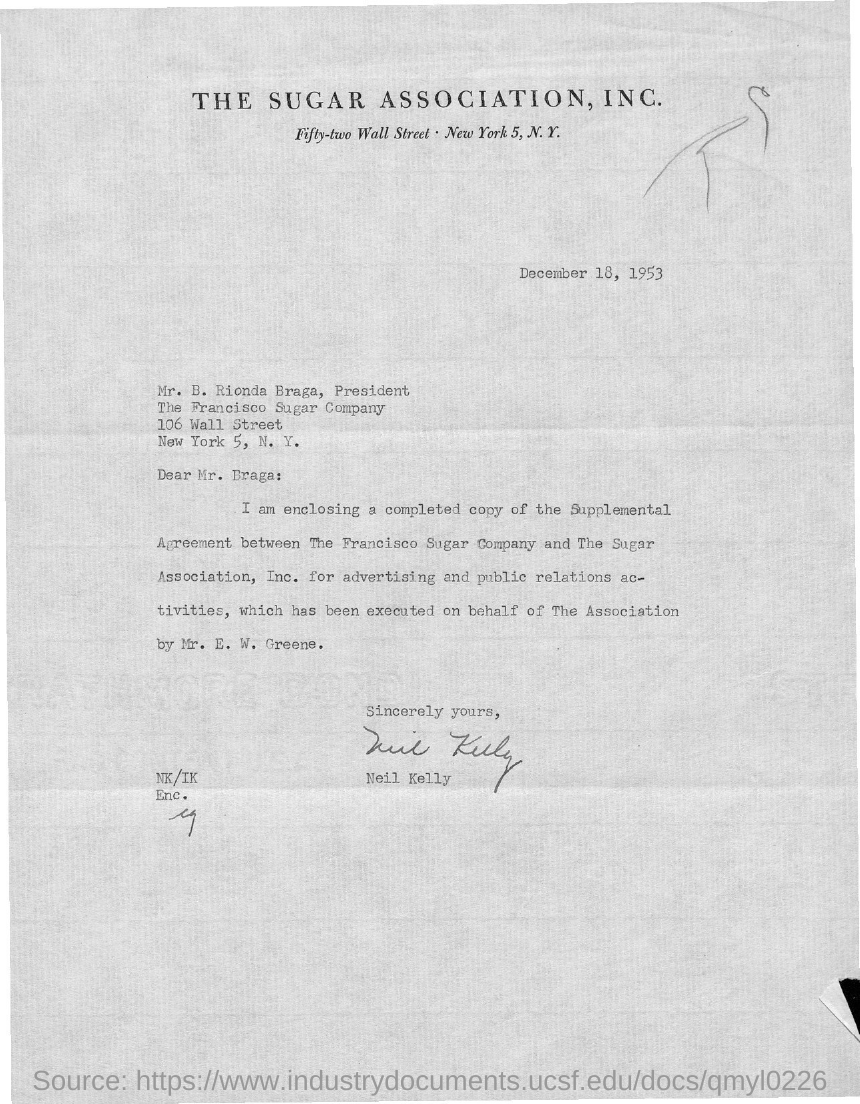Which association is mentioned?
Your response must be concise. The Sugar Association, Inc. When is the document dated?
Your answer should be very brief. December 18, 1953. To whom is the letter addressed?
Make the answer very short. Mr. B. Rionda Braga, President. Of which company is Mr. Braga the president?
Offer a very short reply. The Francisco Sugar Company. Who is the sender?
Your answer should be compact. Neil Kelly. 